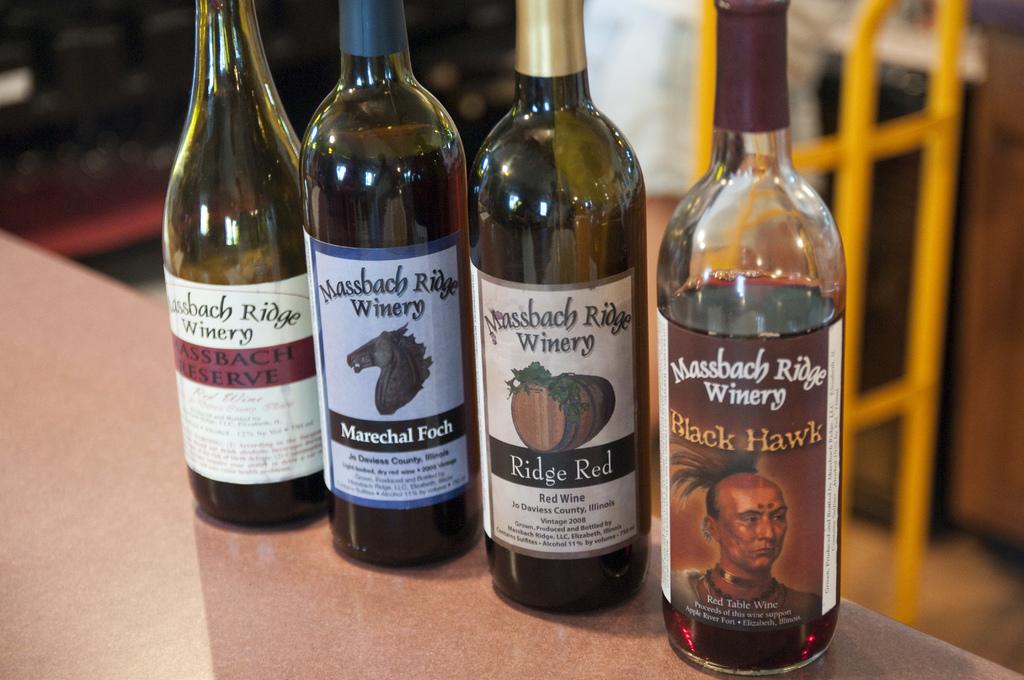What is the anem of the wine on the far left?
Your response must be concise. Massbach reserve. 